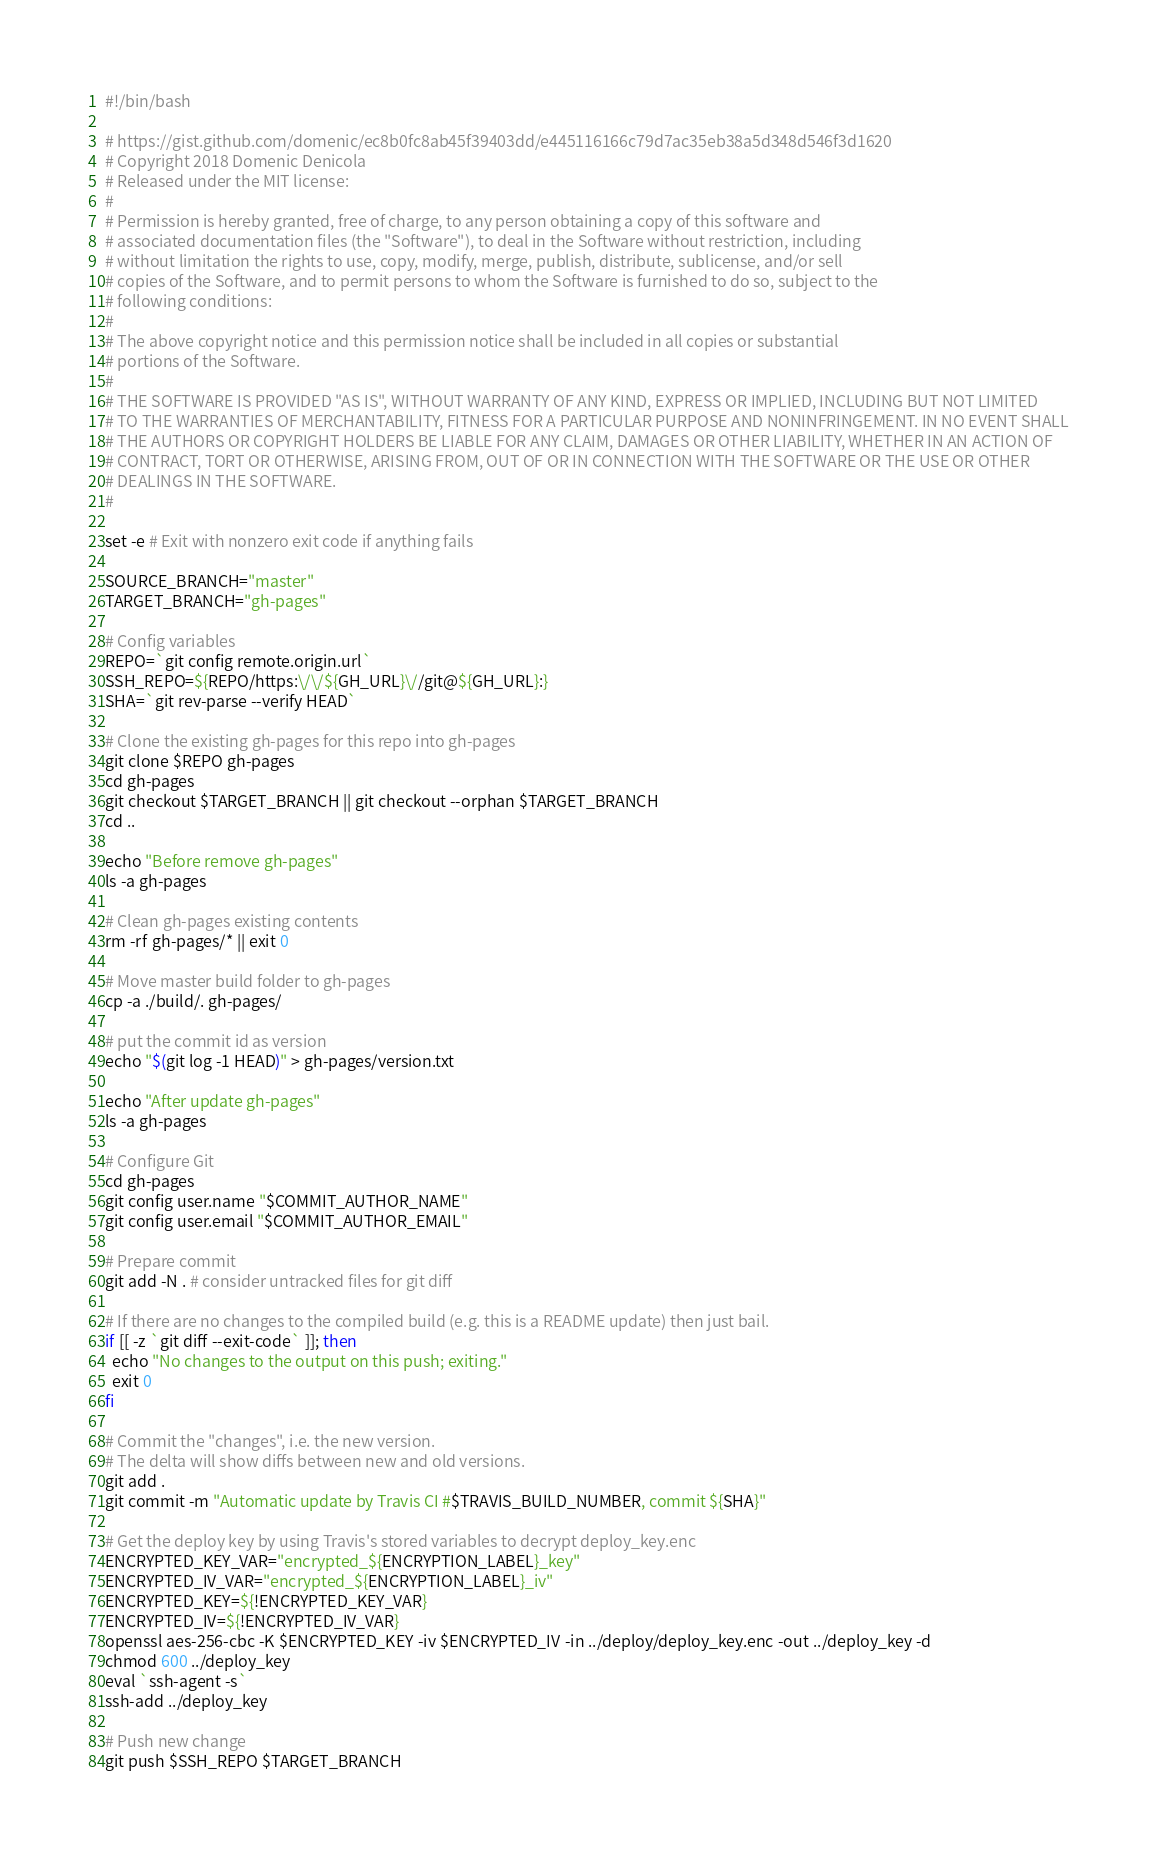<code> <loc_0><loc_0><loc_500><loc_500><_Bash_>#!/bin/bash

# https://gist.github.com/domenic/ec8b0fc8ab45f39403dd/e445116166c79d7ac35eb38a5d348d546f3d1620
# Copyright 2018 Domenic Denicola
# Released under the MIT license:
#
# Permission is hereby granted, free of charge, to any person obtaining a copy of this software and
# associated documentation files (the "Software"), to deal in the Software without restriction, including
# without limitation the rights to use, copy, modify, merge, publish, distribute, sublicense, and/or sell
# copies of the Software, and to permit persons to whom the Software is furnished to do so, subject to the
# following conditions:
#
# The above copyright notice and this permission notice shall be included in all copies or substantial
# portions of the Software.
#
# THE SOFTWARE IS PROVIDED "AS IS", WITHOUT WARRANTY OF ANY KIND, EXPRESS OR IMPLIED, INCLUDING BUT NOT LIMITED
# TO THE WARRANTIES OF MERCHANTABILITY, FITNESS FOR A PARTICULAR PURPOSE AND NONINFRINGEMENT. IN NO EVENT SHALL
# THE AUTHORS OR COPYRIGHT HOLDERS BE LIABLE FOR ANY CLAIM, DAMAGES OR OTHER LIABILITY, WHETHER IN AN ACTION OF
# CONTRACT, TORT OR OTHERWISE, ARISING FROM, OUT OF OR IN CONNECTION WITH THE SOFTWARE OR THE USE OR OTHER
# DEALINGS IN THE SOFTWARE.
#

set -e # Exit with nonzero exit code if anything fails

SOURCE_BRANCH="master"
TARGET_BRANCH="gh-pages"

# Config variables
REPO=`git config remote.origin.url`
SSH_REPO=${REPO/https:\/\/${GH_URL}\//git@${GH_URL}:}
SHA=`git rev-parse --verify HEAD`

# Clone the existing gh-pages for this repo into gh-pages
git clone $REPO gh-pages
cd gh-pages
git checkout $TARGET_BRANCH || git checkout --orphan $TARGET_BRANCH
cd ..

echo "Before remove gh-pages"
ls -a gh-pages

# Clean gh-pages existing contents
rm -rf gh-pages/* || exit 0

# Move master build folder to gh-pages
cp -a ./build/. gh-pages/

# put the commit id as version
echo "$(git log -1 HEAD)" > gh-pages/version.txt

echo "After update gh-pages"
ls -a gh-pages

# Configure Git
cd gh-pages
git config user.name "$COMMIT_AUTHOR_NAME"
git config user.email "$COMMIT_AUTHOR_EMAIL"

# Prepare commit
git add -N . # consider untracked files for git diff

# If there are no changes to the compiled build (e.g. this is a README update) then just bail.
if [[ -z `git diff --exit-code` ]]; then
  echo "No changes to the output on this push; exiting."
  exit 0
fi

# Commit the "changes", i.e. the new version.
# The delta will show diffs between new and old versions.
git add .
git commit -m "Automatic update by Travis CI #$TRAVIS_BUILD_NUMBER, commit ${SHA}"

# Get the deploy key by using Travis's stored variables to decrypt deploy_key.enc
ENCRYPTED_KEY_VAR="encrypted_${ENCRYPTION_LABEL}_key"
ENCRYPTED_IV_VAR="encrypted_${ENCRYPTION_LABEL}_iv"
ENCRYPTED_KEY=${!ENCRYPTED_KEY_VAR}
ENCRYPTED_IV=${!ENCRYPTED_IV_VAR}
openssl aes-256-cbc -K $ENCRYPTED_KEY -iv $ENCRYPTED_IV -in ../deploy/deploy_key.enc -out ../deploy_key -d
chmod 600 ../deploy_key
eval `ssh-agent -s`
ssh-add ../deploy_key

# Push new change
git push $SSH_REPO $TARGET_BRANCH
</code> 